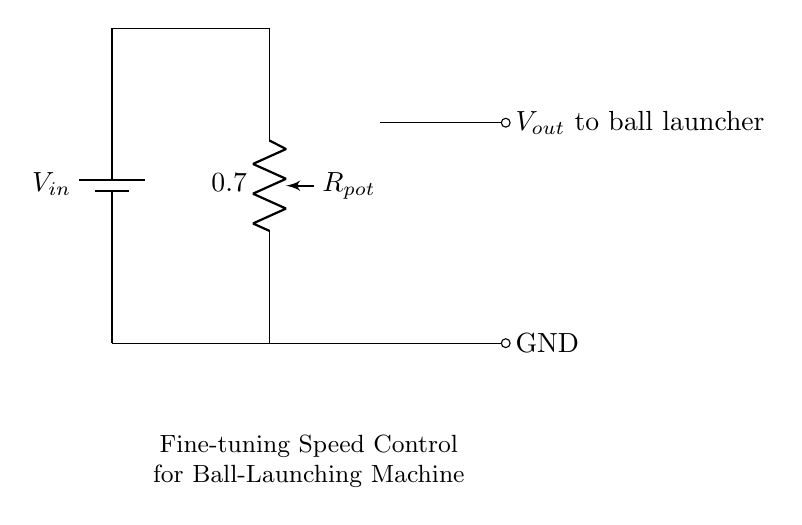What is the input voltage of this circuit? The input voltage is represented by the battery labeled V in, which provides the voltage to the circuit.
Answer: V in What component is used for speed control? The potentiometer labeled R pot is used for speed control, allowing for fine-tuning of the resistance, which adjusts the output voltage.
Answer: R pot What is the output of the voltage divider connected to? The output labeled V out is connected to the ball launcher, indicating that it supplies controlled voltage for launching balls.
Answer: Ball launcher What is the purpose of the potentiometer in this circuit? The potentiometer serves to divide the voltage from the input to provide a variable output voltage, allowing for fine adjustments to speed.
Answer: Fine adjustments What does the symbol connected to GND represent? The GND symbol indicates the ground connection in the circuit, which serves as a reference point for the output voltage.
Answer: Ground How many connections does the potentiometer have in this circuit? The potentiometer typically has three connections: one at the top, one at the bottom, and one for the wiper, which adjusts the output voltage.
Answer: Three connections What is the overall function of this voltage divider circuit? This voltage divider's overall function is to adjust the output voltage to control the speed of the ball-launching machine dynamically.
Answer: Speed control 